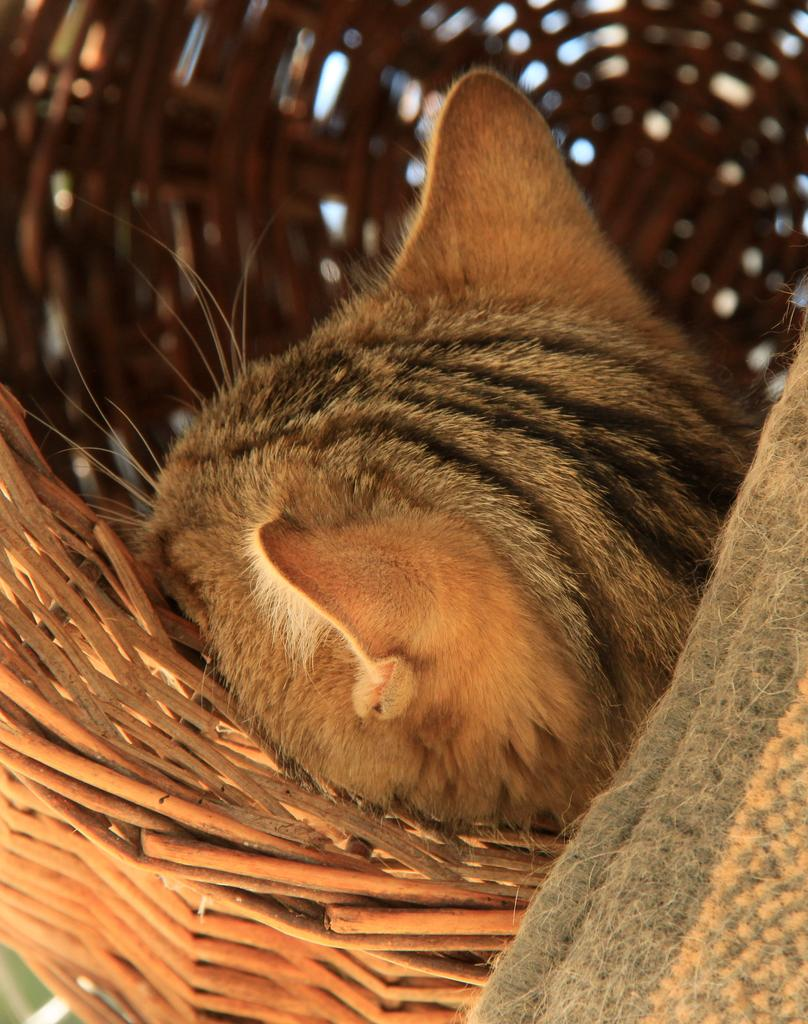What is inside the wicker basket in the image? There is an animal in the wicker basket. Can you describe the object in the bottom right corner of the image? Unfortunately, the provided facts do not give any information about the object in the bottom right corner of the image. What type of lawyer is present in the image? There is no lawyer present in the image. Is there a yam growing near the animal in the wicker basket? There is no yam mentioned or visible in the image. Can you see a volcano in the background of the image? There is no mention of a volcano or any background elements in the provided facts. 